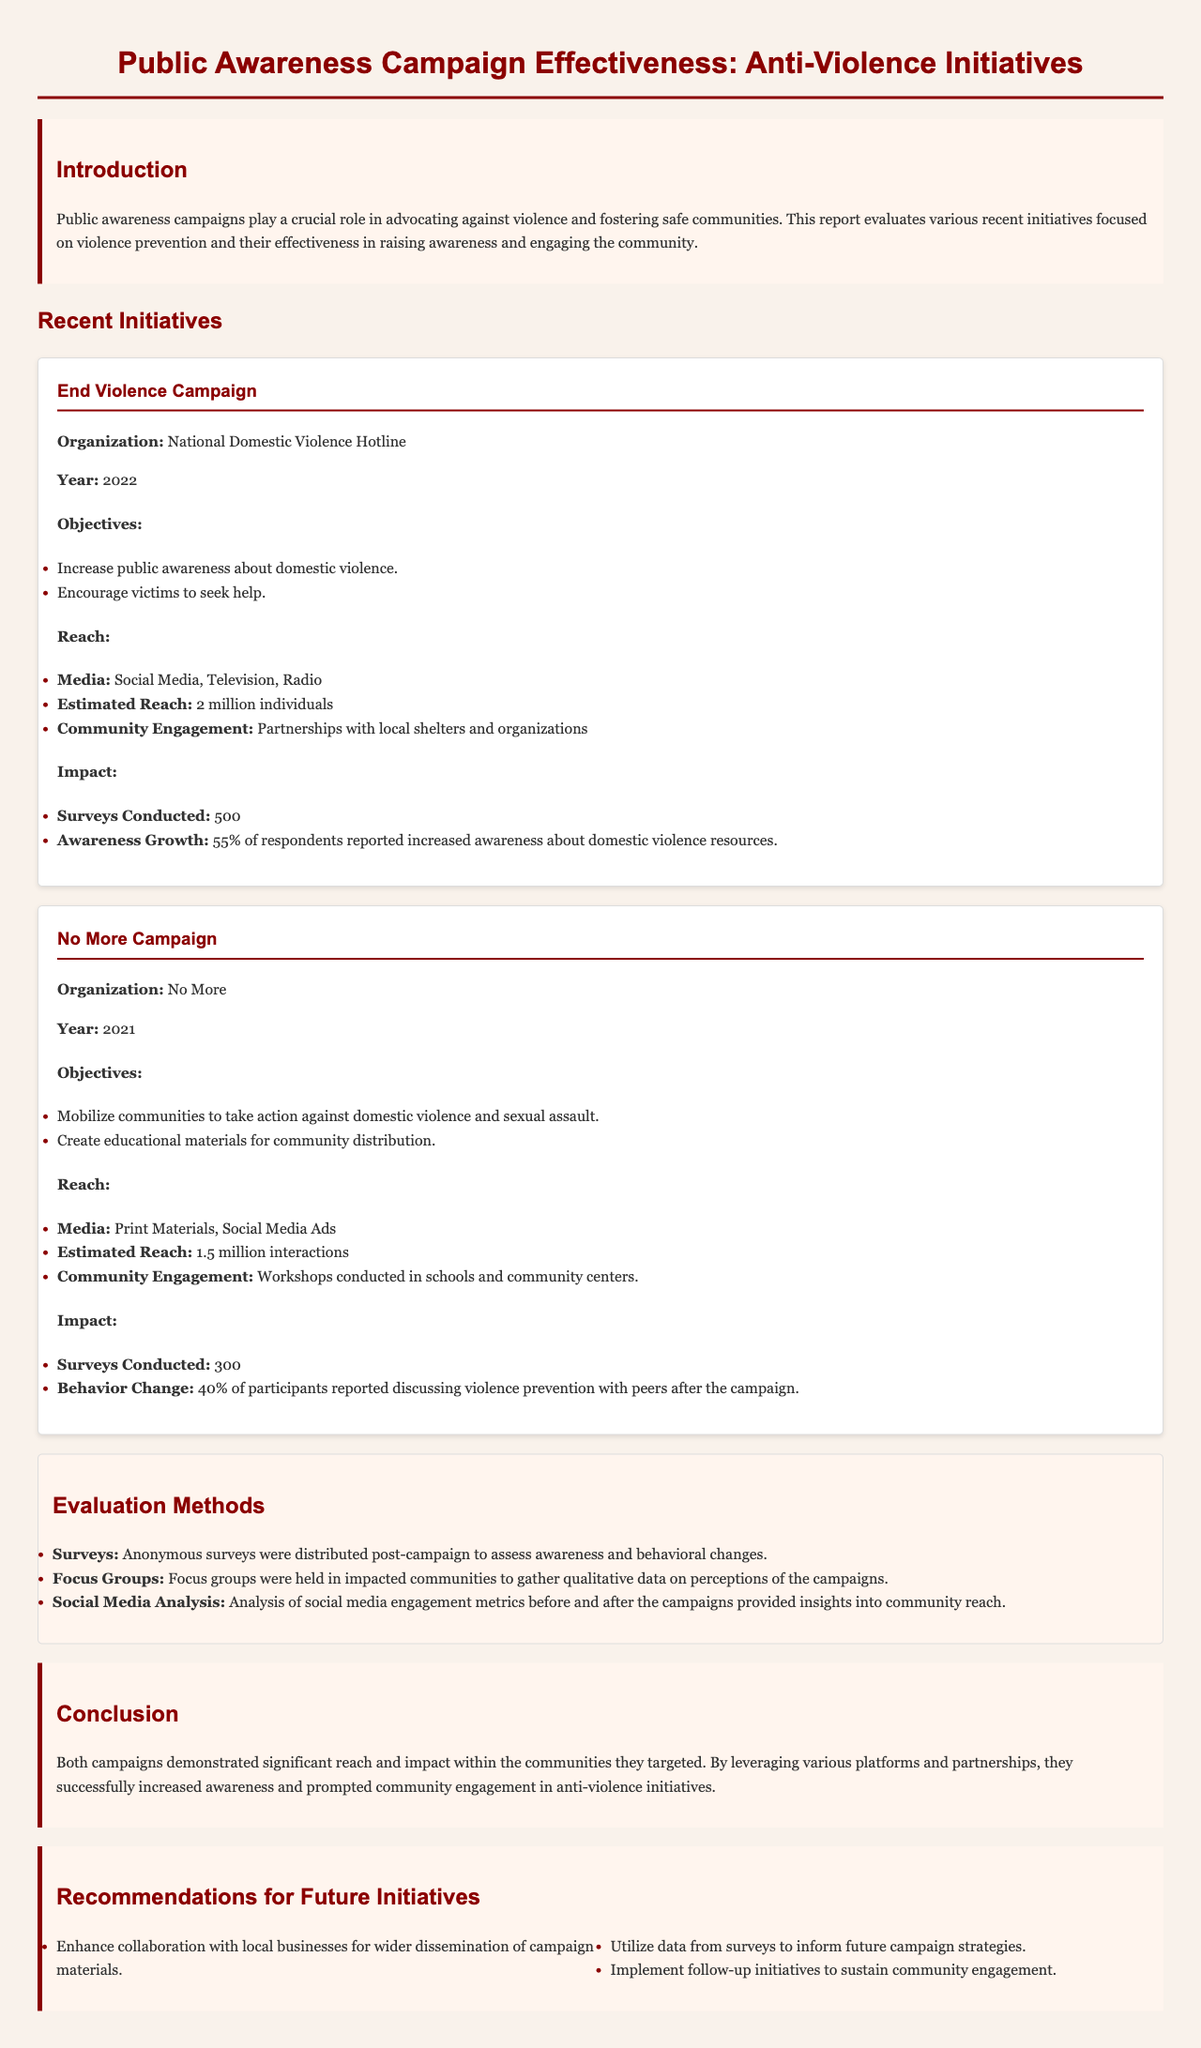What is the name of the first initiative discussed? The first initiative is titled "End Violence Campaign."
Answer: End Violence Campaign Which organization ran the No More Campaign? The document states that the No More Campaign was organized by "No More."
Answer: No More In what year was the End Violence Campaign launched? The End Violence Campaign was launched in the year "2022."
Answer: 2022 How many surveys were conducted for the No More Campaign? The document lists that "300" surveys were conducted for the No More Campaign.
Answer: 300 What percentage of respondents reported increased awareness after the End Violence Campaign? The report indicates that "55%" of respondents reported increased awareness about domestic violence resources.
Answer: 55% What type of media did the End Violence Campaign use to reach the public? The document mentions that the End Violence Campaign utilized "Social Media, Television, Radio."
Answer: Social Media, Television, Radio How did the No More Campaign engage the community? The No More Campaign engaged the community through "Workshops conducted in schools and community centers."
Answer: Workshops conducted in schools and community centers What is one recommendation for future initiatives mentioned in the report? The report recommends to "Enhance collaboration with local businesses for wider dissemination of campaign materials."
Answer: Enhance collaboration with local businesses for wider dissemination of campaign materials 